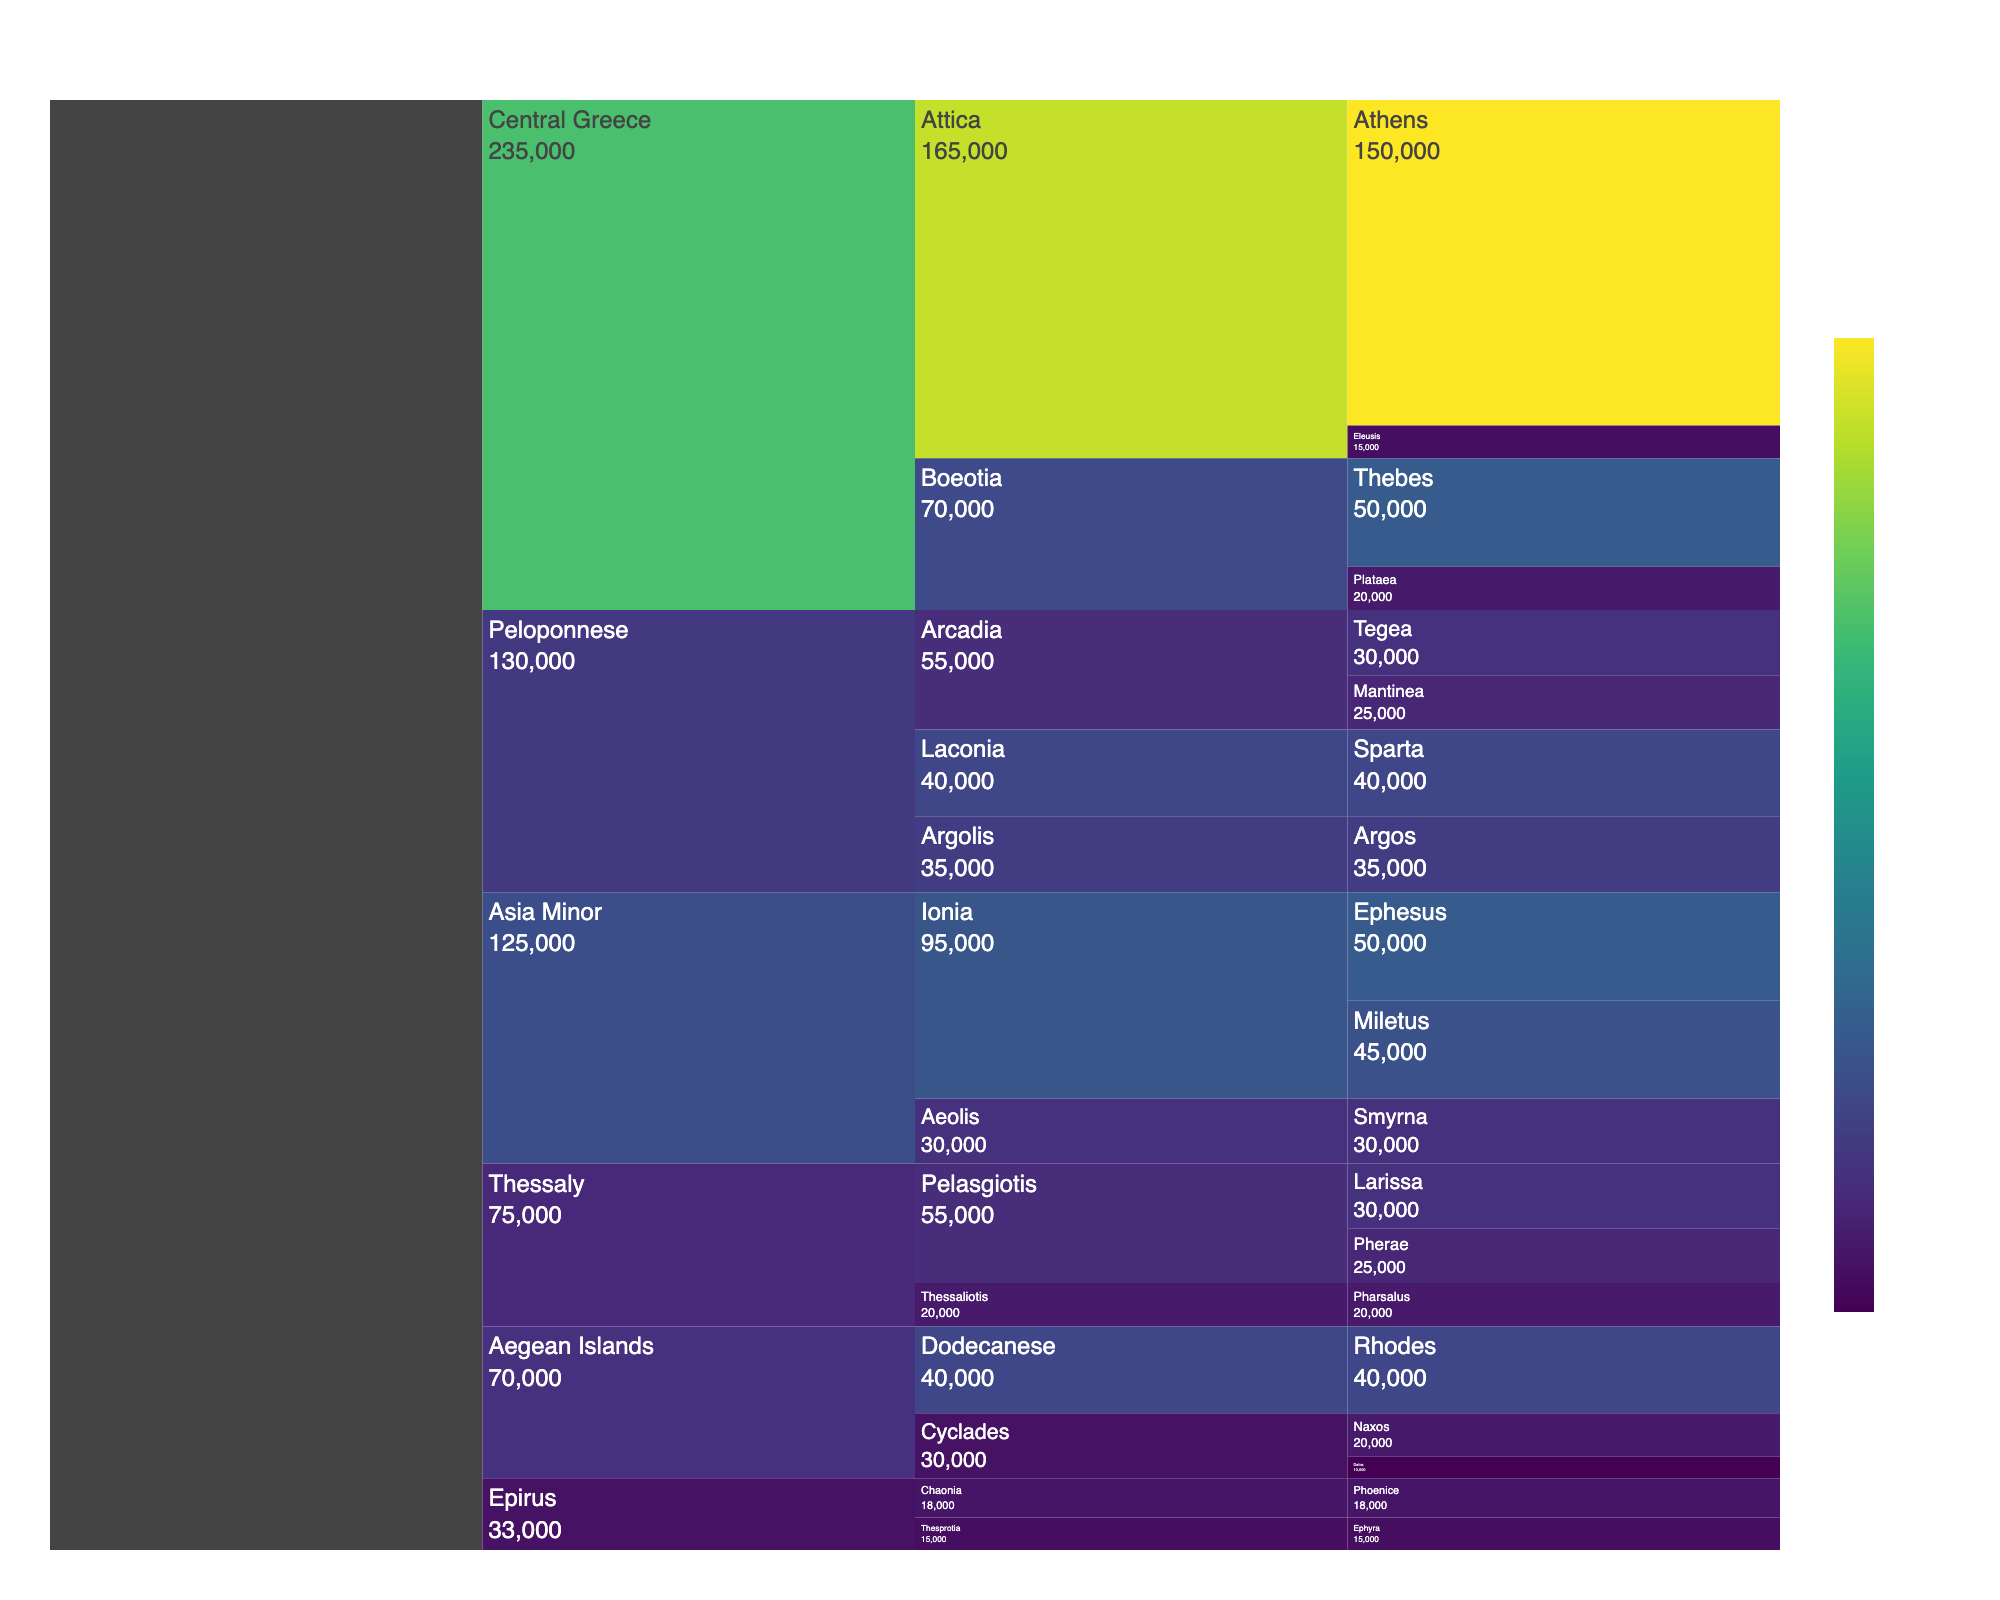What's the title of the Icicle Chart? The title is typically located at the top of the chart and describes the main topic of the visualization. From the provided data and code, the title is "Historical Population Distribution of Ancient Greek City-States".
Answer: Historical Population Distribution of Ancient Greek City-States Which city-state has the highest population? To determine the city-state with the highest population, look at the population values associated with each city-state. Based on the data and the chart, Athens in the region of Central Greece, sub-region Attica, has the highest population of 150,000.
Answer: Athens What is the combined population of the city-states in the region of Peloponnese? To find the combined population, sum the population values of all city-states in the Peloponnese region: Tegea (30,000), Mantinea (25,000), Sparta (40,000), and Argos (35,000). The total is 30,000 + 25,000 + 40,000 + 35,000 = 130,000.
Answer: 130,000 Which region has the most diverse spread of population among its city-states, and why? Look at the population values within each region and evaluate their variability. Central Greece has both the highest (Athens with 150,000) and the relatively smaller population (Eleusis with 15,000) city-states, indicating a diverse spread.
Answer: Central Greece How does the population of Sparta compare to the combined population of Delos and Naxos? First, find the population of Sparta, which is 40,000. Then, sum the populations of Delos (10,000) and Naxos (20,000): 10,000 + 20,000 = 30,000. Comparing them, Sparta has a higher population than the combined value of Delos and Naxos.
Answer: Sparta has a higher population How many regions are represented in the Icicle Chart? Look at the highest level in the Icicle Chart, which represents each region. From the data, the regions are Peloponnese, Central Greece, Thessaly, Epirus, Aegean Islands, and Asia Minor, totaling 6 regions.
Answer: 6 regions What proportion of the total population does the region of Thessaly contribute? First, calculate the total population represented in the chart by summing all population values. Then, sum the population of city-states in Thessaly (30,000 + 25,000 + 20,000 = 75,000). Finally, divide the population of Thessaly by the total population and convert to a percentage. Total population is 462,000; hence, proportion is (75,000 / 462,000) * 100 ≈ 16.2%.
Answer: 16.2% Which sub-region within Asia Minor has the smallest population, and what is that population? Within Asia Minor, compare the populations of the sub-regions Ionia and Aeolis. Aeolis (Smyrna, 30,000) has a smaller population compared to Ionia (Ephesus, 50,000 + Miletus, 45,000 = 95,000), making Aeolis the sub-region with the smallest population.
Answer: Aeolis, 30,000 Is the population of Miletus closer to the population of Larissa or Plataea? Miletus has a population of 45,000. Compare this to Larissa (30,000) and Plataea (20,000). The difference is 45,000 - 30,000 = 15,000 for Larissa and 45,000 - 20,000 = 25,000 for Plataea. Thus, the population of Miletus is closer to that of Larissa.
Answer: Larissa 